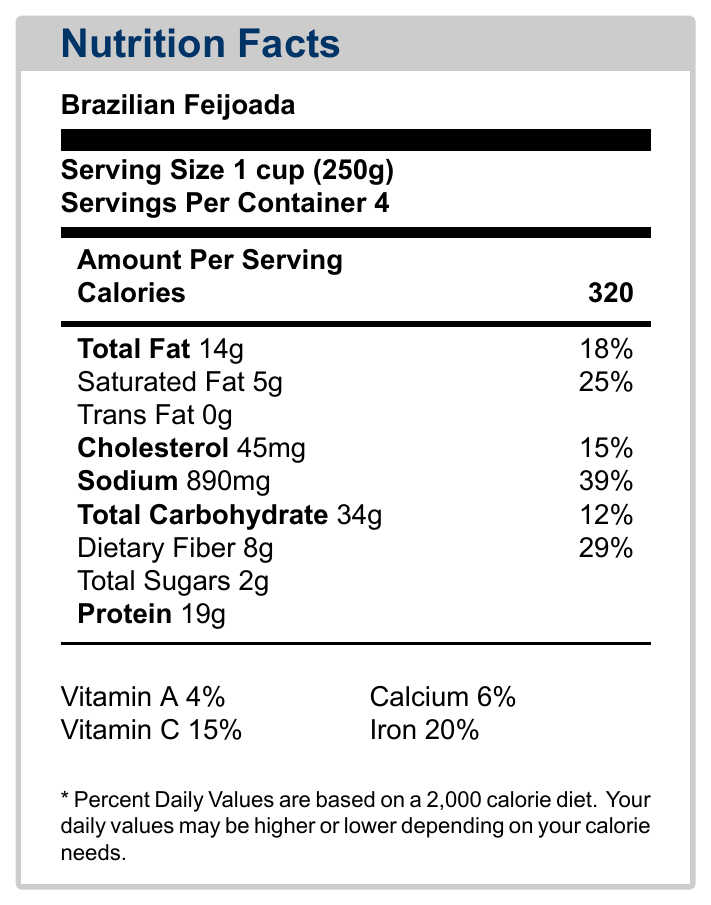what is the serving size for Brazilian Feijoada? The serving size is clearly indicated in the Nutrition Facts label for Brazilian Feijoada.
Answer: 1 cup (250g) how many grams of protein are in one serving of Brazilian Feijoada? The Nutrition Facts label specifies the amount of protein per serving.
Answer: 19 grams what percentage of daily value of sodium does one serving of Brazilian Feijoada provide? The label states that one serving provides 39% of the daily value of sodium.
Answer: 39% how many servings are contained in one package of Japanese Miso Soup? The Nutrition Facts label for Japanese Miso Soup indicates there are 2 servings per container.
Answer: 2 what is the total carbohydrate content in one serving of Japanese Miso Soup? According to the label, one serving of Japanese Miso Soup contains 5 grams of total carbohydrates.
Answer: 5 grams which dish has the highest amount of iron per serving? 
    A. Brazilian Feijoada 
    B. Japanese Miso Soup
    C. Greek Moussaka Brazilian Feijoada has 20% of the daily value of iron per serving, which is higher than the iron content in Japanese Miso Soup (5%) and Greek Moussaka (10%).
Answer: A which of the following dishes contain trans fat?
    1. Brazilian Feijoada
    2. Japanese Miso Soup
    3. Greek Moussaka
    4. None of the above Greek Moussaka contains 0.5 grams of trans fat, while the other dishes contain no trans fat.
Answer: 3 does Brazilian Feijoada contain dietary fiber? The Nutrition Facts label indicates that Brazilian Feijoada contains 8 grams of dietary fiber per serving.
Answer: Yes which dish offers the highest amount of protein per serving? The Nutrition Facts label lists 19 grams of protein per serving of Brazilian Feijoada, which is higher compared to Japanese Miso Soup (3 grams) and Greek Moussaka (15 grams).
Answer: Brazilian Feijoada summarize the document. The document outlines the different features of the exhibit, including the dishes showcased, interactive tools available, educational content provided, and curator insights on the importance of hands-on learning and cultural sensitivity.
Answer: The document describes an interactive digital exhibit titled "Global Flavors: Nutritional Diversity Across Cultures" which includes Nutrition Facts Labels for three dishes: Brazilian Feijoada, Japanese Miso Soup, and Greek Moussaka. Various interactive features like a Nutritional Comparison Tool and Regional Nutrient Map are included, along with educational content and curator insights. how many calories are in one serving of Greek Moussaka? The Nutrition Facts label for Greek Moussaka shows that one serving contains 280 calories.
Answer: 280 calories which dish contains the most calcium per serving? The Nutrition Facts labels show that Greek Moussaka contains 15% of the daily value of calcium, which is more than Brazilian Feijoada (6%) and Japanese Miso Soup (2%).
Answer: Greek Moussaka what is the predominant nutrient in Japanese Miso Soup? The Nutrition Facts label indicates that Japanese Miso Soup has 630mg of sodium per serving, making it the predominant nutrient.
Answer: Sodium does the document provide the historical influences on Brazilian Feijoada? The provided document does not include specific historical details for Brazilian Feijoada. It describes the exhibit's overall themes but not individual dish histories.
Answer: Not enough information 